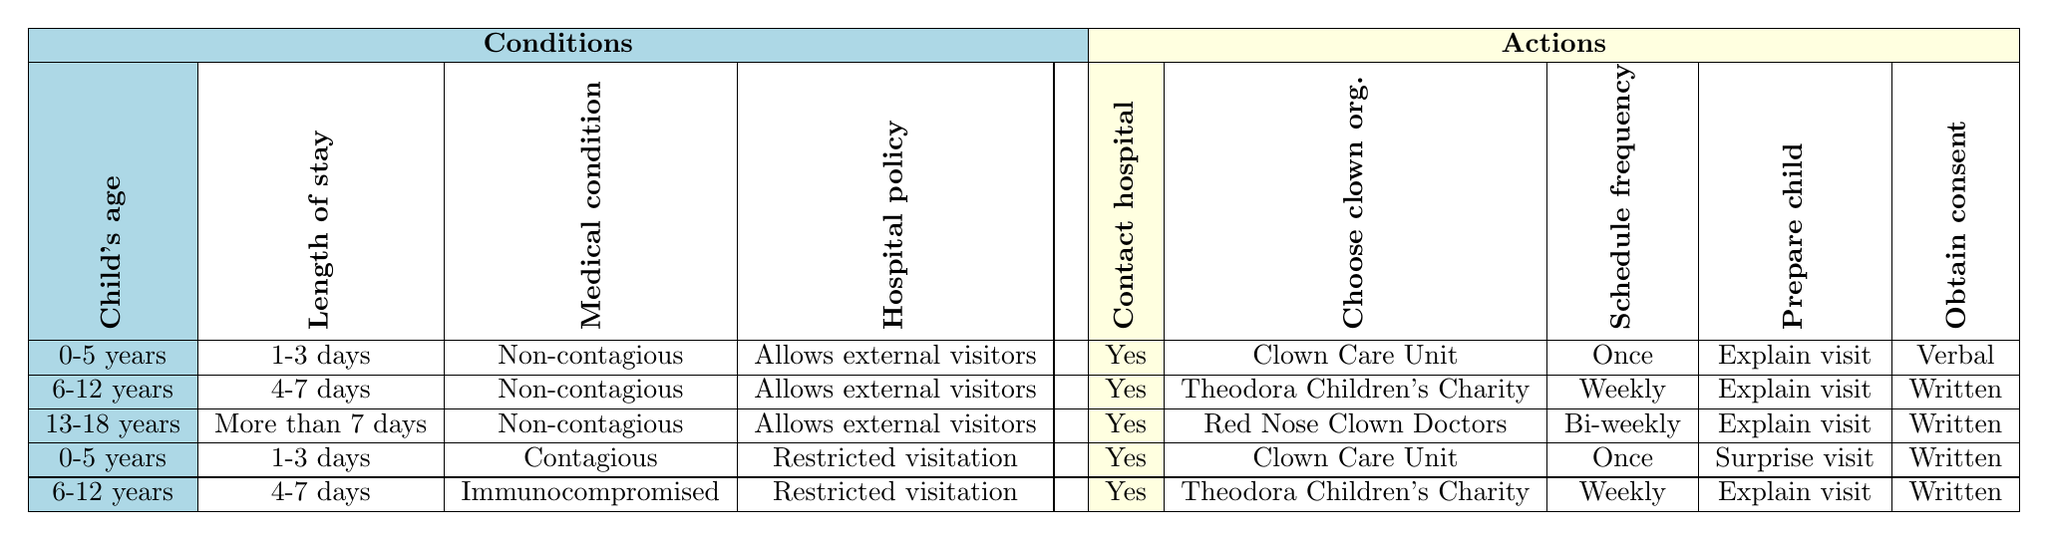What actions should be taken if a child is 6-12 years old and has a length of stay of 4-7 days? According to the table, for a child aged 6-12 years who has a length of stay of 4-7 days, the actions are: Contact hospital administration - Yes, Choose clown organization - Theodora Children's Charity, Schedule visit frequency - Weekly, Prepare child - Explain visit, Obtain consent - Written.
Answer: Yes, Theodora Children's Charity, Weekly, Explain visit, Written Is a surprise visit recommended for children with a contagious medical condition? If we look at the row for children aged 0-5 years with contagious conditions under restricted visitation, it indicates that the action is to prepare the child for a surprise visit. Therefore, a surprise visit is recommended for this age group in this situation but not necessarily for others without context.
Answer: Yes, for 0-5 years with contagious condition What is the scheduled visit frequency for a child over 13 years with a non-contagious condition and allowed external visitors? The table specifies that for a child aged 13-18 with a non-contagious condition and allowed external visitors, the scheduled visit frequency is bi-weekly.
Answer: Bi-weekly How many clown organizations are suggested for children with a non-contagious medical condition? In the table, there are three instances for non-contagious conditions across different age groups. They are Clown Care Unit, Theodora Children's Charity, and Red Nose Clown Doctors, leading to a total of three organizations.
Answer: Three Which clown organization is recommended for children aged 0-5 years with a non-contagious condition who are allowed external visitors? The table indicates that for children aged 0-5 years with a non-contagious condition and allowed external visitors, the recommended clown organization is the Clown Care Unit.
Answer: Clown Care Unit What type of consent is required for a 6-12 years old child with an immunocompromised condition? The table shows that for a child aged 6-12 with an immunocompromised condition under restricted visitation, written consent is required.
Answer: Written Do children aged 0-5 years and those with contagious conditions require a verbal consent? According to the table, children aged 0-5 years with contagious conditions under restricted visitation require written consent, not verbal. Therefore, the answer is no; they do not require verbal consent in this scenario.
Answer: No If a child has a length of stay of more than 7 days and is infected with a contagious condition, which clown organization can visit? In the table, there is no entry for children with a contagious condition and a length of stay of more than 7 days. As such, no organization is suggested, indicating that visits may not be permitted in this scenario.
Answer: None recommended 